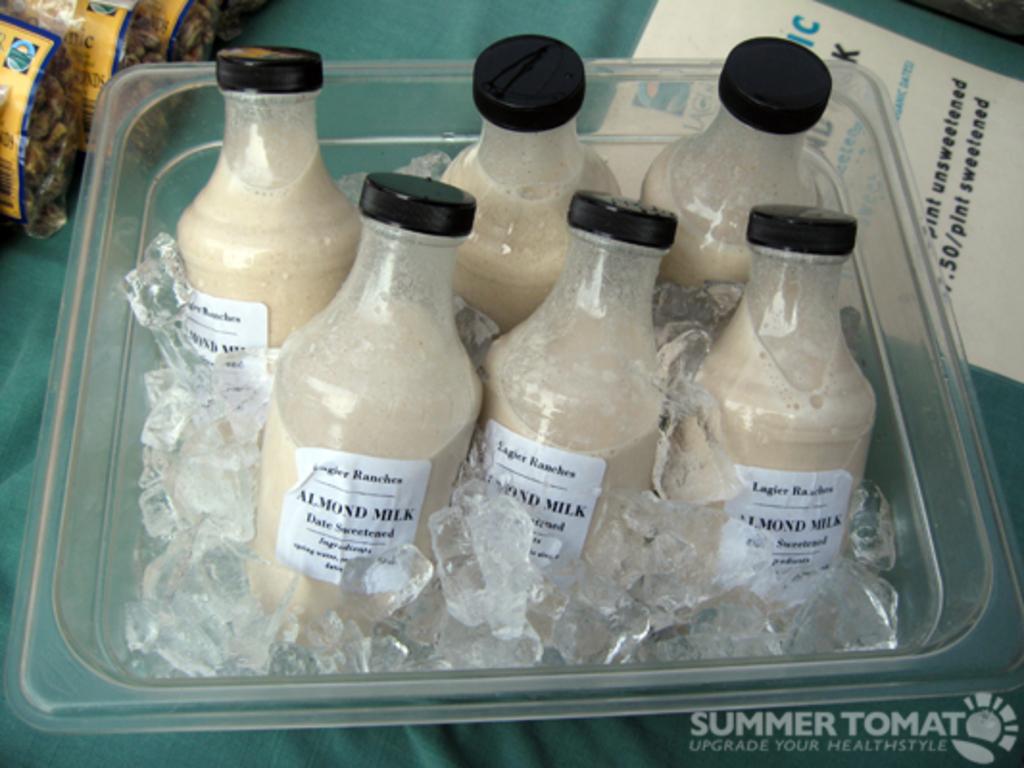What kind of milk is in the chilled ice?
Your answer should be very brief. Almond milk. What is summer tomat's motto?
Provide a succinct answer. Upgrade your healthstyle. 